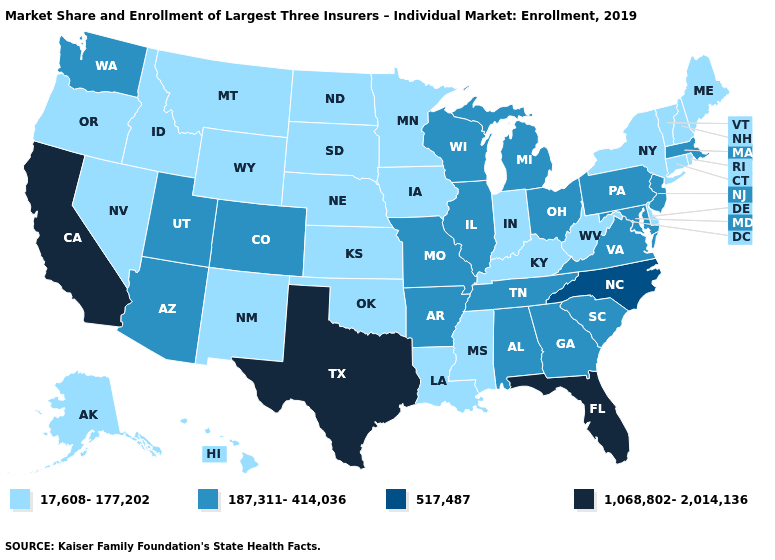Does Arkansas have the highest value in the USA?
Answer briefly. No. Name the states that have a value in the range 187,311-414,036?
Write a very short answer. Alabama, Arizona, Arkansas, Colorado, Georgia, Illinois, Maryland, Massachusetts, Michigan, Missouri, New Jersey, Ohio, Pennsylvania, South Carolina, Tennessee, Utah, Virginia, Washington, Wisconsin. What is the value of Alabama?
Answer briefly. 187,311-414,036. What is the highest value in states that border Rhode Island?
Quick response, please. 187,311-414,036. What is the lowest value in the USA?
Quick response, please. 17,608-177,202. Name the states that have a value in the range 17,608-177,202?
Write a very short answer. Alaska, Connecticut, Delaware, Hawaii, Idaho, Indiana, Iowa, Kansas, Kentucky, Louisiana, Maine, Minnesota, Mississippi, Montana, Nebraska, Nevada, New Hampshire, New Mexico, New York, North Dakota, Oklahoma, Oregon, Rhode Island, South Dakota, Vermont, West Virginia, Wyoming. What is the highest value in the MidWest ?
Keep it brief. 187,311-414,036. Among the states that border Idaho , which have the lowest value?
Answer briefly. Montana, Nevada, Oregon, Wyoming. Does the first symbol in the legend represent the smallest category?
Give a very brief answer. Yes. What is the highest value in the USA?
Give a very brief answer. 1,068,802-2,014,136. Among the states that border Maryland , which have the lowest value?
Be succinct. Delaware, West Virginia. What is the highest value in the USA?
Concise answer only. 1,068,802-2,014,136. What is the lowest value in states that border Virginia?
Concise answer only. 17,608-177,202. What is the value of Wisconsin?
Keep it brief. 187,311-414,036. Among the states that border Mississippi , which have the lowest value?
Keep it brief. Louisiana. 